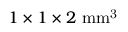Convert formula to latex. <formula><loc_0><loc_0><loc_500><loc_500>1 \times 1 \times 2 m m ^ { 3 }</formula> 